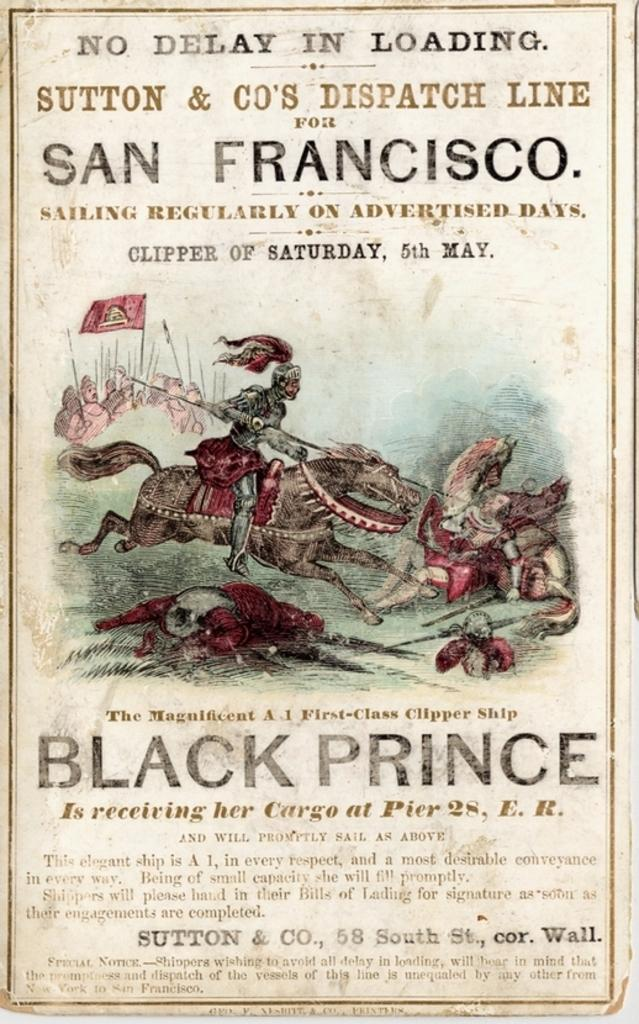<image>
Create a compact narrative representing the image presented. A sign for the Black Prince and the date of Saturday May 5th. 